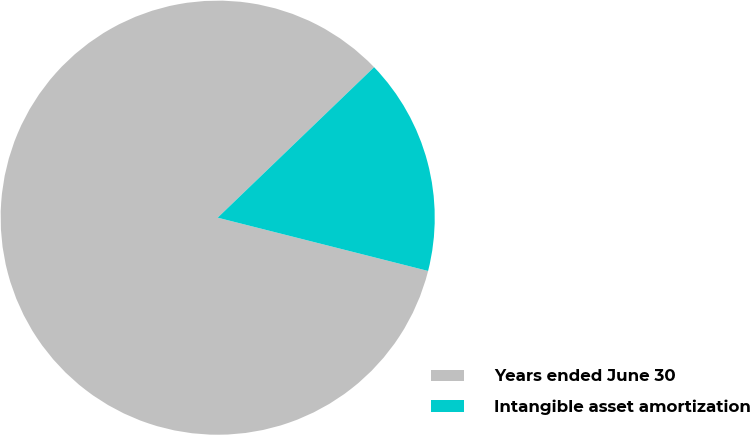<chart> <loc_0><loc_0><loc_500><loc_500><pie_chart><fcel>Years ended June 30<fcel>Intangible asset amortization<nl><fcel>83.86%<fcel>16.14%<nl></chart> 